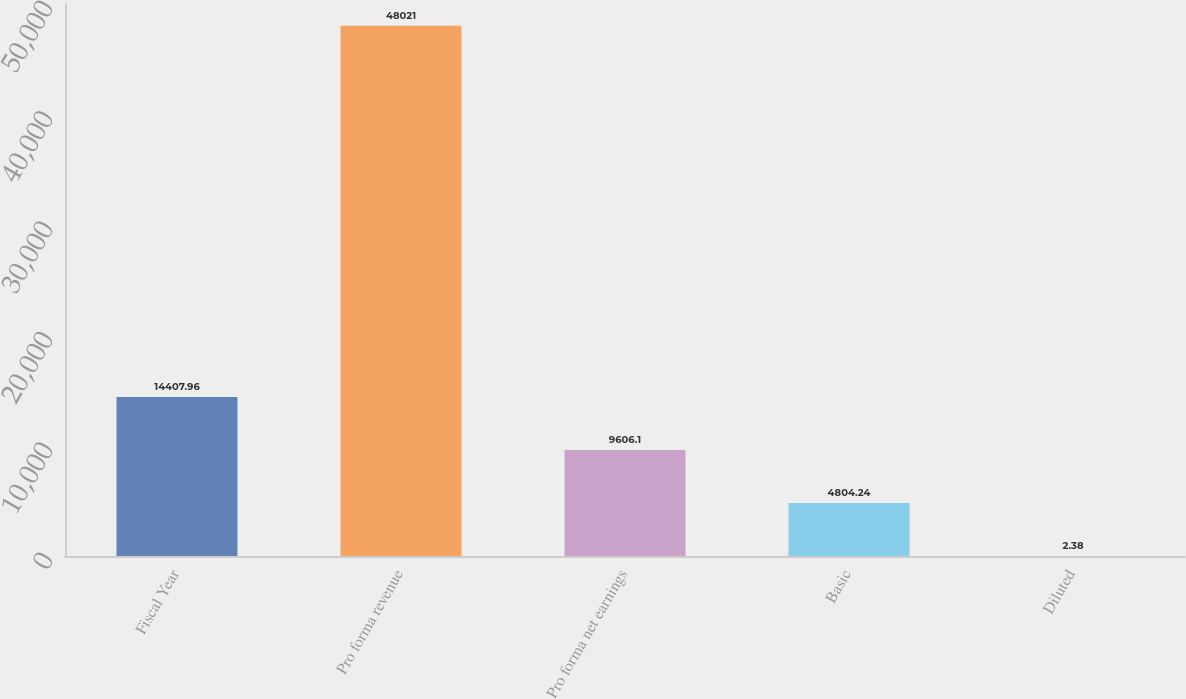Convert chart to OTSL. <chart><loc_0><loc_0><loc_500><loc_500><bar_chart><fcel>Fiscal Year<fcel>Pro forma revenue<fcel>Pro forma net earnings<fcel>Basic<fcel>Diluted<nl><fcel>14408<fcel>48021<fcel>9606.1<fcel>4804.24<fcel>2.38<nl></chart> 